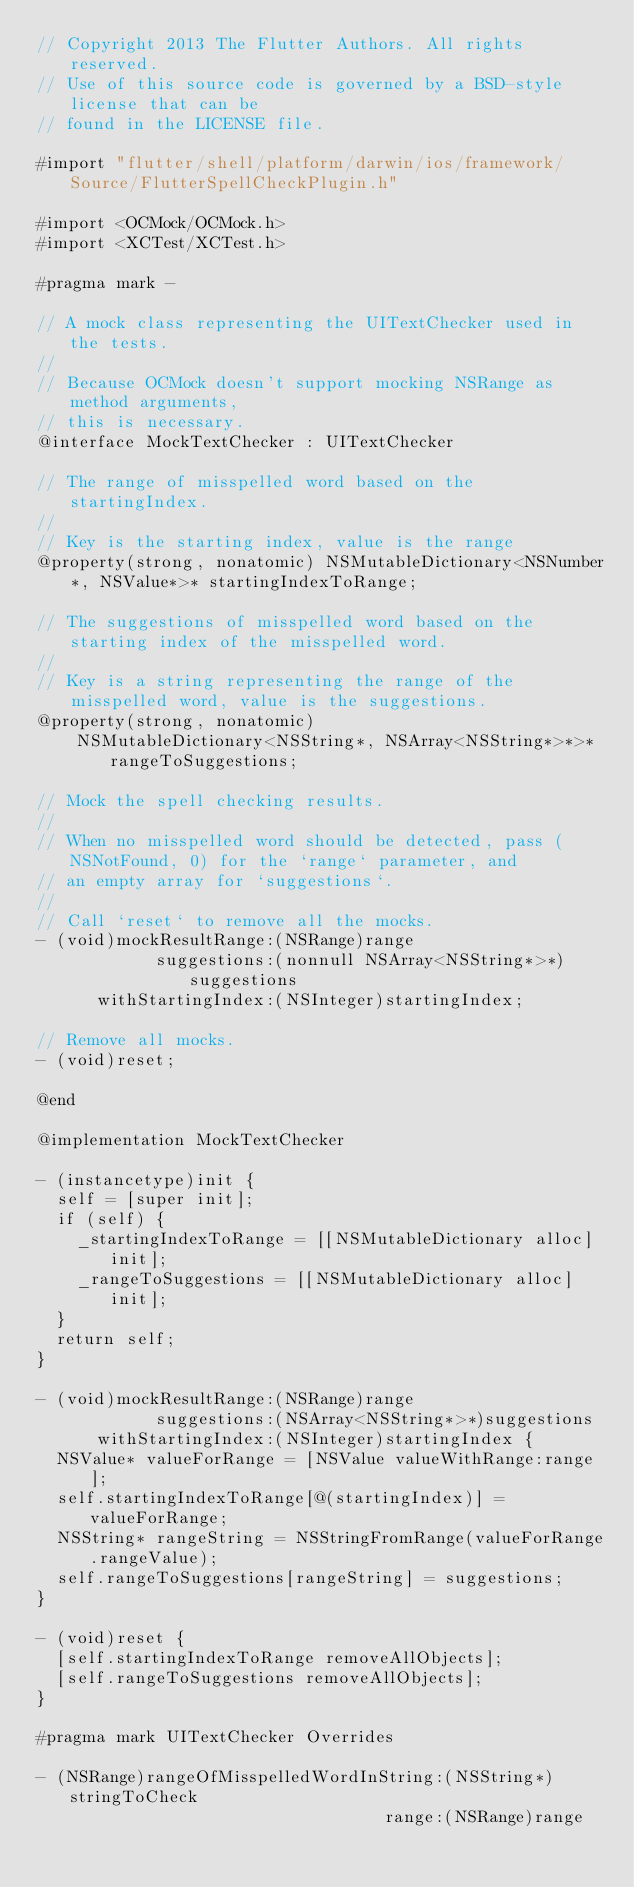<code> <loc_0><loc_0><loc_500><loc_500><_ObjectiveC_>// Copyright 2013 The Flutter Authors. All rights reserved.
// Use of this source code is governed by a BSD-style license that can be
// found in the LICENSE file.

#import "flutter/shell/platform/darwin/ios/framework/Source/FlutterSpellCheckPlugin.h"

#import <OCMock/OCMock.h>
#import <XCTest/XCTest.h>

#pragma mark -

// A mock class representing the UITextChecker used in the tests.
//
// Because OCMock doesn't support mocking NSRange as method arguments,
// this is necessary.
@interface MockTextChecker : UITextChecker

// The range of misspelled word based on the startingIndex.
//
// Key is the starting index, value is the range
@property(strong, nonatomic) NSMutableDictionary<NSNumber*, NSValue*>* startingIndexToRange;

// The suggestions of misspelled word based on the starting index of the misspelled word.
//
// Key is a string representing the range of the misspelled word, value is the suggestions.
@property(strong, nonatomic)
    NSMutableDictionary<NSString*, NSArray<NSString*>*>* rangeToSuggestions;

// Mock the spell checking results.
//
// When no misspelled word should be detected, pass (NSNotFound, 0) for the `range` parameter, and
// an empty array for `suggestions`.
//
// Call `reset` to remove all the mocks.
- (void)mockResultRange:(NSRange)range
            suggestions:(nonnull NSArray<NSString*>*)suggestions
      withStartingIndex:(NSInteger)startingIndex;

// Remove all mocks.
- (void)reset;

@end

@implementation MockTextChecker

- (instancetype)init {
  self = [super init];
  if (self) {
    _startingIndexToRange = [[NSMutableDictionary alloc] init];
    _rangeToSuggestions = [[NSMutableDictionary alloc] init];
  }
  return self;
}

- (void)mockResultRange:(NSRange)range
            suggestions:(NSArray<NSString*>*)suggestions
      withStartingIndex:(NSInteger)startingIndex {
  NSValue* valueForRange = [NSValue valueWithRange:range];
  self.startingIndexToRange[@(startingIndex)] = valueForRange;
  NSString* rangeString = NSStringFromRange(valueForRange.rangeValue);
  self.rangeToSuggestions[rangeString] = suggestions;
}

- (void)reset {
  [self.startingIndexToRange removeAllObjects];
  [self.rangeToSuggestions removeAllObjects];
}

#pragma mark UITextChecker Overrides

- (NSRange)rangeOfMisspelledWordInString:(NSString*)stringToCheck
                                   range:(NSRange)range</code> 